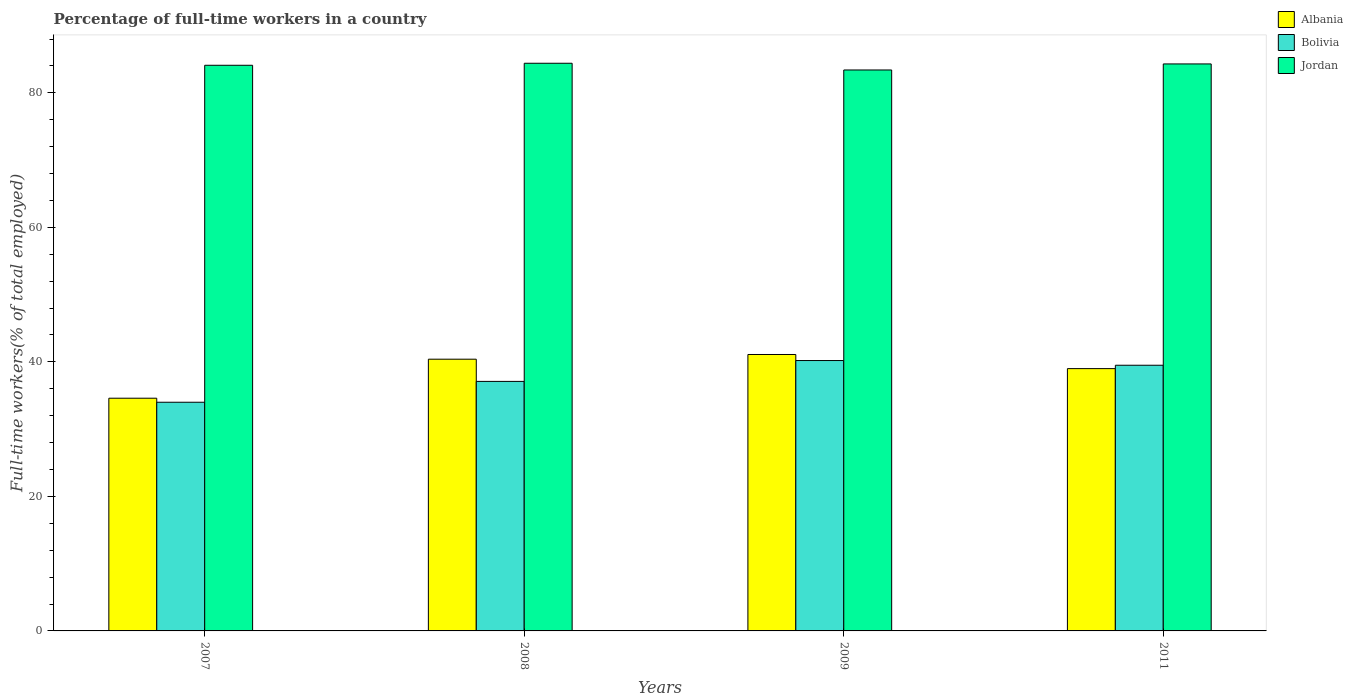How many different coloured bars are there?
Your answer should be compact. 3. Are the number of bars per tick equal to the number of legend labels?
Give a very brief answer. Yes. Are the number of bars on each tick of the X-axis equal?
Ensure brevity in your answer.  Yes. How many bars are there on the 2nd tick from the left?
Keep it short and to the point. 3. How many bars are there on the 2nd tick from the right?
Offer a very short reply. 3. What is the label of the 3rd group of bars from the left?
Offer a very short reply. 2009. In how many cases, is the number of bars for a given year not equal to the number of legend labels?
Make the answer very short. 0. Across all years, what is the maximum percentage of full-time workers in Albania?
Make the answer very short. 41.1. Across all years, what is the minimum percentage of full-time workers in Jordan?
Offer a very short reply. 83.4. In which year was the percentage of full-time workers in Jordan maximum?
Provide a short and direct response. 2008. In which year was the percentage of full-time workers in Bolivia minimum?
Give a very brief answer. 2007. What is the total percentage of full-time workers in Jordan in the graph?
Your answer should be compact. 336.2. What is the difference between the percentage of full-time workers in Albania in 2007 and that in 2008?
Give a very brief answer. -5.8. What is the difference between the percentage of full-time workers in Jordan in 2007 and the percentage of full-time workers in Albania in 2008?
Ensure brevity in your answer.  43.7. What is the average percentage of full-time workers in Bolivia per year?
Give a very brief answer. 37.7. In the year 2007, what is the difference between the percentage of full-time workers in Albania and percentage of full-time workers in Jordan?
Provide a short and direct response. -49.5. What is the ratio of the percentage of full-time workers in Jordan in 2007 to that in 2009?
Keep it short and to the point. 1.01. Is the difference between the percentage of full-time workers in Albania in 2007 and 2008 greater than the difference between the percentage of full-time workers in Jordan in 2007 and 2008?
Offer a terse response. No. What is the difference between the highest and the second highest percentage of full-time workers in Jordan?
Keep it short and to the point. 0.1. What is the difference between the highest and the lowest percentage of full-time workers in Bolivia?
Your answer should be compact. 6.2. In how many years, is the percentage of full-time workers in Albania greater than the average percentage of full-time workers in Albania taken over all years?
Make the answer very short. 3. Is the sum of the percentage of full-time workers in Bolivia in 2009 and 2011 greater than the maximum percentage of full-time workers in Albania across all years?
Offer a terse response. Yes. What does the 3rd bar from the left in 2008 represents?
Your answer should be compact. Jordan. What does the 2nd bar from the right in 2009 represents?
Give a very brief answer. Bolivia. Is it the case that in every year, the sum of the percentage of full-time workers in Jordan and percentage of full-time workers in Albania is greater than the percentage of full-time workers in Bolivia?
Your answer should be very brief. Yes. Are all the bars in the graph horizontal?
Offer a terse response. No. What is the difference between two consecutive major ticks on the Y-axis?
Give a very brief answer. 20. Are the values on the major ticks of Y-axis written in scientific E-notation?
Offer a very short reply. No. Where does the legend appear in the graph?
Offer a very short reply. Top right. What is the title of the graph?
Give a very brief answer. Percentage of full-time workers in a country. Does "Korea (Democratic)" appear as one of the legend labels in the graph?
Provide a short and direct response. No. What is the label or title of the Y-axis?
Offer a terse response. Full-time workers(% of total employed). What is the Full-time workers(% of total employed) of Albania in 2007?
Provide a succinct answer. 34.6. What is the Full-time workers(% of total employed) of Bolivia in 2007?
Give a very brief answer. 34. What is the Full-time workers(% of total employed) in Jordan in 2007?
Offer a terse response. 84.1. What is the Full-time workers(% of total employed) of Albania in 2008?
Keep it short and to the point. 40.4. What is the Full-time workers(% of total employed) of Bolivia in 2008?
Give a very brief answer. 37.1. What is the Full-time workers(% of total employed) of Jordan in 2008?
Your answer should be compact. 84.4. What is the Full-time workers(% of total employed) of Albania in 2009?
Ensure brevity in your answer.  41.1. What is the Full-time workers(% of total employed) of Bolivia in 2009?
Ensure brevity in your answer.  40.2. What is the Full-time workers(% of total employed) in Jordan in 2009?
Make the answer very short. 83.4. What is the Full-time workers(% of total employed) of Albania in 2011?
Give a very brief answer. 39. What is the Full-time workers(% of total employed) in Bolivia in 2011?
Your answer should be compact. 39.5. What is the Full-time workers(% of total employed) of Jordan in 2011?
Your answer should be compact. 84.3. Across all years, what is the maximum Full-time workers(% of total employed) in Albania?
Ensure brevity in your answer.  41.1. Across all years, what is the maximum Full-time workers(% of total employed) in Bolivia?
Make the answer very short. 40.2. Across all years, what is the maximum Full-time workers(% of total employed) of Jordan?
Offer a terse response. 84.4. Across all years, what is the minimum Full-time workers(% of total employed) in Albania?
Offer a terse response. 34.6. Across all years, what is the minimum Full-time workers(% of total employed) of Jordan?
Provide a short and direct response. 83.4. What is the total Full-time workers(% of total employed) in Albania in the graph?
Provide a short and direct response. 155.1. What is the total Full-time workers(% of total employed) in Bolivia in the graph?
Offer a terse response. 150.8. What is the total Full-time workers(% of total employed) of Jordan in the graph?
Your response must be concise. 336.2. What is the difference between the Full-time workers(% of total employed) in Bolivia in 2007 and that in 2008?
Offer a terse response. -3.1. What is the difference between the Full-time workers(% of total employed) in Jordan in 2007 and that in 2008?
Provide a succinct answer. -0.3. What is the difference between the Full-time workers(% of total employed) of Jordan in 2007 and that in 2009?
Provide a succinct answer. 0.7. What is the difference between the Full-time workers(% of total employed) in Jordan in 2007 and that in 2011?
Offer a terse response. -0.2. What is the difference between the Full-time workers(% of total employed) in Albania in 2008 and that in 2009?
Provide a succinct answer. -0.7. What is the difference between the Full-time workers(% of total employed) of Bolivia in 2008 and that in 2009?
Your answer should be compact. -3.1. What is the difference between the Full-time workers(% of total employed) in Jordan in 2008 and that in 2011?
Offer a terse response. 0.1. What is the difference between the Full-time workers(% of total employed) in Albania in 2007 and the Full-time workers(% of total employed) in Jordan in 2008?
Your answer should be compact. -49.8. What is the difference between the Full-time workers(% of total employed) in Bolivia in 2007 and the Full-time workers(% of total employed) in Jordan in 2008?
Provide a short and direct response. -50.4. What is the difference between the Full-time workers(% of total employed) in Albania in 2007 and the Full-time workers(% of total employed) in Jordan in 2009?
Offer a terse response. -48.8. What is the difference between the Full-time workers(% of total employed) of Bolivia in 2007 and the Full-time workers(% of total employed) of Jordan in 2009?
Your answer should be very brief. -49.4. What is the difference between the Full-time workers(% of total employed) in Albania in 2007 and the Full-time workers(% of total employed) in Bolivia in 2011?
Provide a short and direct response. -4.9. What is the difference between the Full-time workers(% of total employed) in Albania in 2007 and the Full-time workers(% of total employed) in Jordan in 2011?
Offer a very short reply. -49.7. What is the difference between the Full-time workers(% of total employed) in Bolivia in 2007 and the Full-time workers(% of total employed) in Jordan in 2011?
Provide a short and direct response. -50.3. What is the difference between the Full-time workers(% of total employed) of Albania in 2008 and the Full-time workers(% of total employed) of Jordan in 2009?
Ensure brevity in your answer.  -43. What is the difference between the Full-time workers(% of total employed) of Bolivia in 2008 and the Full-time workers(% of total employed) of Jordan in 2009?
Offer a very short reply. -46.3. What is the difference between the Full-time workers(% of total employed) of Albania in 2008 and the Full-time workers(% of total employed) of Bolivia in 2011?
Ensure brevity in your answer.  0.9. What is the difference between the Full-time workers(% of total employed) in Albania in 2008 and the Full-time workers(% of total employed) in Jordan in 2011?
Offer a very short reply. -43.9. What is the difference between the Full-time workers(% of total employed) in Bolivia in 2008 and the Full-time workers(% of total employed) in Jordan in 2011?
Offer a terse response. -47.2. What is the difference between the Full-time workers(% of total employed) in Albania in 2009 and the Full-time workers(% of total employed) in Bolivia in 2011?
Your response must be concise. 1.6. What is the difference between the Full-time workers(% of total employed) in Albania in 2009 and the Full-time workers(% of total employed) in Jordan in 2011?
Offer a very short reply. -43.2. What is the difference between the Full-time workers(% of total employed) in Bolivia in 2009 and the Full-time workers(% of total employed) in Jordan in 2011?
Give a very brief answer. -44.1. What is the average Full-time workers(% of total employed) in Albania per year?
Keep it short and to the point. 38.77. What is the average Full-time workers(% of total employed) in Bolivia per year?
Offer a terse response. 37.7. What is the average Full-time workers(% of total employed) of Jordan per year?
Your response must be concise. 84.05. In the year 2007, what is the difference between the Full-time workers(% of total employed) of Albania and Full-time workers(% of total employed) of Bolivia?
Offer a very short reply. 0.6. In the year 2007, what is the difference between the Full-time workers(% of total employed) in Albania and Full-time workers(% of total employed) in Jordan?
Keep it short and to the point. -49.5. In the year 2007, what is the difference between the Full-time workers(% of total employed) of Bolivia and Full-time workers(% of total employed) of Jordan?
Make the answer very short. -50.1. In the year 2008, what is the difference between the Full-time workers(% of total employed) of Albania and Full-time workers(% of total employed) of Jordan?
Offer a very short reply. -44. In the year 2008, what is the difference between the Full-time workers(% of total employed) in Bolivia and Full-time workers(% of total employed) in Jordan?
Give a very brief answer. -47.3. In the year 2009, what is the difference between the Full-time workers(% of total employed) in Albania and Full-time workers(% of total employed) in Jordan?
Your response must be concise. -42.3. In the year 2009, what is the difference between the Full-time workers(% of total employed) of Bolivia and Full-time workers(% of total employed) of Jordan?
Offer a terse response. -43.2. In the year 2011, what is the difference between the Full-time workers(% of total employed) in Albania and Full-time workers(% of total employed) in Jordan?
Your answer should be compact. -45.3. In the year 2011, what is the difference between the Full-time workers(% of total employed) of Bolivia and Full-time workers(% of total employed) of Jordan?
Give a very brief answer. -44.8. What is the ratio of the Full-time workers(% of total employed) of Albania in 2007 to that in 2008?
Keep it short and to the point. 0.86. What is the ratio of the Full-time workers(% of total employed) of Bolivia in 2007 to that in 2008?
Offer a very short reply. 0.92. What is the ratio of the Full-time workers(% of total employed) in Albania in 2007 to that in 2009?
Your answer should be very brief. 0.84. What is the ratio of the Full-time workers(% of total employed) of Bolivia in 2007 to that in 2009?
Make the answer very short. 0.85. What is the ratio of the Full-time workers(% of total employed) in Jordan in 2007 to that in 2009?
Give a very brief answer. 1.01. What is the ratio of the Full-time workers(% of total employed) in Albania in 2007 to that in 2011?
Your answer should be compact. 0.89. What is the ratio of the Full-time workers(% of total employed) in Bolivia in 2007 to that in 2011?
Offer a terse response. 0.86. What is the ratio of the Full-time workers(% of total employed) of Jordan in 2007 to that in 2011?
Give a very brief answer. 1. What is the ratio of the Full-time workers(% of total employed) of Albania in 2008 to that in 2009?
Give a very brief answer. 0.98. What is the ratio of the Full-time workers(% of total employed) in Bolivia in 2008 to that in 2009?
Give a very brief answer. 0.92. What is the ratio of the Full-time workers(% of total employed) in Albania in 2008 to that in 2011?
Offer a terse response. 1.04. What is the ratio of the Full-time workers(% of total employed) of Bolivia in 2008 to that in 2011?
Keep it short and to the point. 0.94. What is the ratio of the Full-time workers(% of total employed) of Jordan in 2008 to that in 2011?
Offer a terse response. 1. What is the ratio of the Full-time workers(% of total employed) of Albania in 2009 to that in 2011?
Keep it short and to the point. 1.05. What is the ratio of the Full-time workers(% of total employed) of Bolivia in 2009 to that in 2011?
Make the answer very short. 1.02. What is the ratio of the Full-time workers(% of total employed) of Jordan in 2009 to that in 2011?
Provide a succinct answer. 0.99. What is the difference between the highest and the second highest Full-time workers(% of total employed) in Bolivia?
Keep it short and to the point. 0.7. What is the difference between the highest and the second highest Full-time workers(% of total employed) in Jordan?
Provide a succinct answer. 0.1. What is the difference between the highest and the lowest Full-time workers(% of total employed) in Bolivia?
Your response must be concise. 6.2. What is the difference between the highest and the lowest Full-time workers(% of total employed) in Jordan?
Give a very brief answer. 1. 